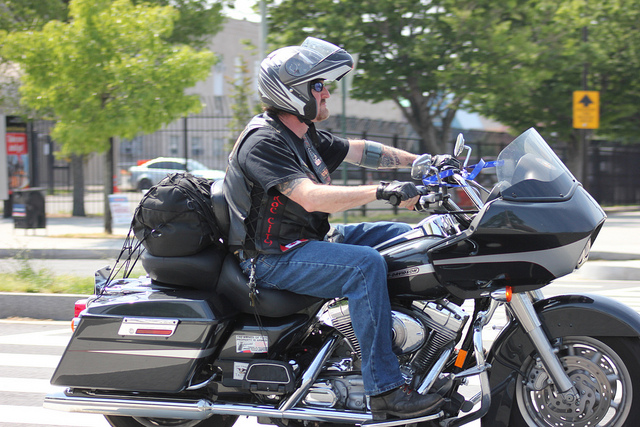How many people are on the bike? 1 